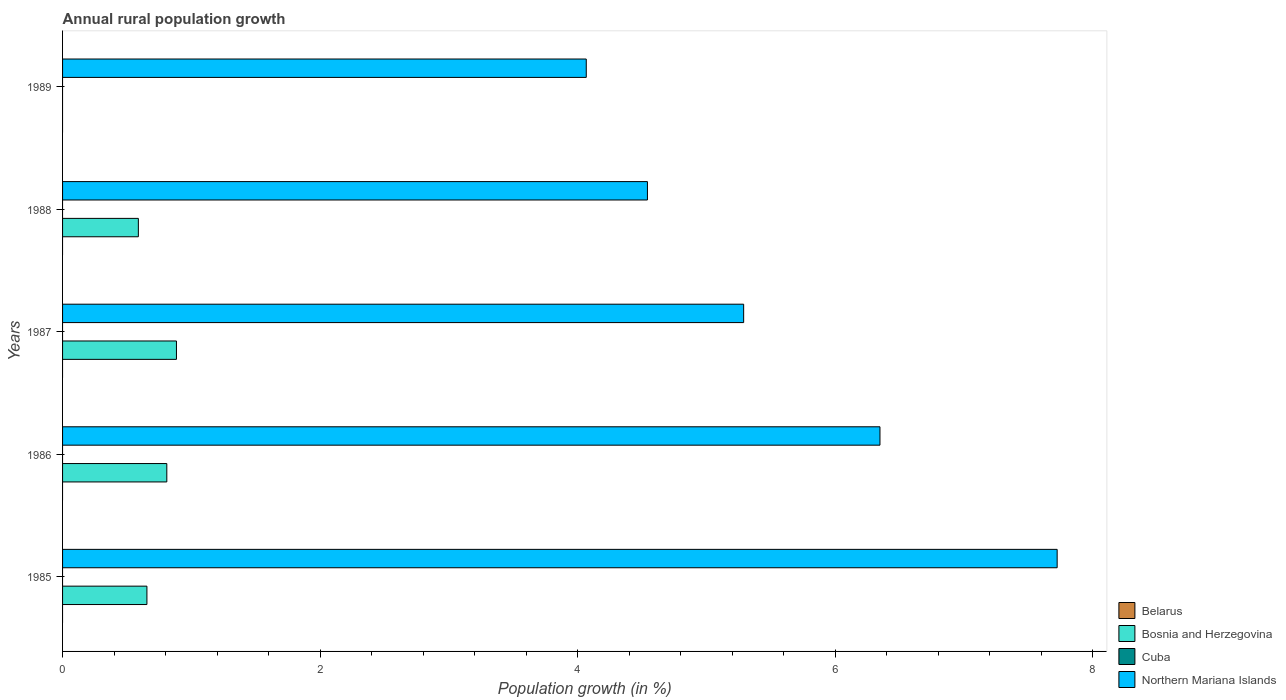Are the number of bars on each tick of the Y-axis equal?
Make the answer very short. No. How many bars are there on the 5th tick from the top?
Your answer should be very brief. 2. How many bars are there on the 1st tick from the bottom?
Provide a succinct answer. 2. In how many cases, is the number of bars for a given year not equal to the number of legend labels?
Offer a very short reply. 5. What is the percentage of rural population growth in Belarus in 1989?
Provide a short and direct response. 0. Across all years, what is the maximum percentage of rural population growth in Northern Mariana Islands?
Provide a short and direct response. 7.72. Across all years, what is the minimum percentage of rural population growth in Cuba?
Offer a very short reply. 0. What is the difference between the percentage of rural population growth in Bosnia and Herzegovina in 1986 and that in 1987?
Keep it short and to the point. -0.07. What is the difference between the percentage of rural population growth in Northern Mariana Islands in 1988 and the percentage of rural population growth in Cuba in 1989?
Offer a terse response. 4.54. What is the average percentage of rural population growth in Cuba per year?
Make the answer very short. 0. In the year 1987, what is the difference between the percentage of rural population growth in Northern Mariana Islands and percentage of rural population growth in Bosnia and Herzegovina?
Provide a short and direct response. 4.4. In how many years, is the percentage of rural population growth in Cuba greater than 0.4 %?
Keep it short and to the point. 0. What is the ratio of the percentage of rural population growth in Northern Mariana Islands in 1985 to that in 1988?
Give a very brief answer. 1.7. What is the difference between the highest and the second highest percentage of rural population growth in Bosnia and Herzegovina?
Ensure brevity in your answer.  0.07. What is the difference between the highest and the lowest percentage of rural population growth in Bosnia and Herzegovina?
Ensure brevity in your answer.  0.88. In how many years, is the percentage of rural population growth in Cuba greater than the average percentage of rural population growth in Cuba taken over all years?
Provide a succinct answer. 0. Is it the case that in every year, the sum of the percentage of rural population growth in Northern Mariana Islands and percentage of rural population growth in Cuba is greater than the sum of percentage of rural population growth in Bosnia and Herzegovina and percentage of rural population growth in Belarus?
Provide a succinct answer. Yes. How many bars are there?
Your answer should be very brief. 9. Are all the bars in the graph horizontal?
Provide a succinct answer. Yes. How many years are there in the graph?
Offer a very short reply. 5. What is the difference between two consecutive major ticks on the X-axis?
Your response must be concise. 2. Are the values on the major ticks of X-axis written in scientific E-notation?
Keep it short and to the point. No. Does the graph contain any zero values?
Provide a short and direct response. Yes. Does the graph contain grids?
Make the answer very short. No. How are the legend labels stacked?
Provide a succinct answer. Vertical. What is the title of the graph?
Give a very brief answer. Annual rural population growth. Does "Togo" appear as one of the legend labels in the graph?
Provide a succinct answer. No. What is the label or title of the X-axis?
Make the answer very short. Population growth (in %). What is the Population growth (in %) in Bosnia and Herzegovina in 1985?
Ensure brevity in your answer.  0.66. What is the Population growth (in %) of Northern Mariana Islands in 1985?
Provide a short and direct response. 7.72. What is the Population growth (in %) of Bosnia and Herzegovina in 1986?
Offer a very short reply. 0.81. What is the Population growth (in %) in Northern Mariana Islands in 1986?
Offer a terse response. 6.35. What is the Population growth (in %) in Bosnia and Herzegovina in 1987?
Your answer should be compact. 0.88. What is the Population growth (in %) of Cuba in 1987?
Keep it short and to the point. 0. What is the Population growth (in %) of Northern Mariana Islands in 1987?
Give a very brief answer. 5.29. What is the Population growth (in %) of Bosnia and Herzegovina in 1988?
Your answer should be compact. 0.59. What is the Population growth (in %) in Northern Mariana Islands in 1988?
Provide a short and direct response. 4.54. What is the Population growth (in %) in Belarus in 1989?
Your answer should be compact. 0. What is the Population growth (in %) of Cuba in 1989?
Your answer should be compact. 0. What is the Population growth (in %) of Northern Mariana Islands in 1989?
Your answer should be very brief. 4.07. Across all years, what is the maximum Population growth (in %) in Bosnia and Herzegovina?
Offer a terse response. 0.88. Across all years, what is the maximum Population growth (in %) of Northern Mariana Islands?
Give a very brief answer. 7.72. Across all years, what is the minimum Population growth (in %) in Bosnia and Herzegovina?
Provide a short and direct response. 0. Across all years, what is the minimum Population growth (in %) in Northern Mariana Islands?
Provide a succinct answer. 4.07. What is the total Population growth (in %) of Bosnia and Herzegovina in the graph?
Your answer should be compact. 2.94. What is the total Population growth (in %) in Cuba in the graph?
Offer a terse response. 0. What is the total Population growth (in %) in Northern Mariana Islands in the graph?
Provide a short and direct response. 27.97. What is the difference between the Population growth (in %) of Bosnia and Herzegovina in 1985 and that in 1986?
Offer a terse response. -0.15. What is the difference between the Population growth (in %) in Northern Mariana Islands in 1985 and that in 1986?
Ensure brevity in your answer.  1.38. What is the difference between the Population growth (in %) of Bosnia and Herzegovina in 1985 and that in 1987?
Make the answer very short. -0.23. What is the difference between the Population growth (in %) in Northern Mariana Islands in 1985 and that in 1987?
Your answer should be compact. 2.43. What is the difference between the Population growth (in %) in Bosnia and Herzegovina in 1985 and that in 1988?
Ensure brevity in your answer.  0.07. What is the difference between the Population growth (in %) of Northern Mariana Islands in 1985 and that in 1988?
Your answer should be compact. 3.18. What is the difference between the Population growth (in %) in Northern Mariana Islands in 1985 and that in 1989?
Your answer should be very brief. 3.66. What is the difference between the Population growth (in %) in Bosnia and Herzegovina in 1986 and that in 1987?
Offer a very short reply. -0.07. What is the difference between the Population growth (in %) in Northern Mariana Islands in 1986 and that in 1987?
Give a very brief answer. 1.06. What is the difference between the Population growth (in %) in Bosnia and Herzegovina in 1986 and that in 1988?
Offer a terse response. 0.22. What is the difference between the Population growth (in %) in Northern Mariana Islands in 1986 and that in 1988?
Your response must be concise. 1.81. What is the difference between the Population growth (in %) of Northern Mariana Islands in 1986 and that in 1989?
Ensure brevity in your answer.  2.28. What is the difference between the Population growth (in %) of Bosnia and Herzegovina in 1987 and that in 1988?
Keep it short and to the point. 0.3. What is the difference between the Population growth (in %) in Northern Mariana Islands in 1987 and that in 1988?
Provide a succinct answer. 0.75. What is the difference between the Population growth (in %) of Northern Mariana Islands in 1987 and that in 1989?
Offer a terse response. 1.22. What is the difference between the Population growth (in %) of Northern Mariana Islands in 1988 and that in 1989?
Give a very brief answer. 0.47. What is the difference between the Population growth (in %) of Bosnia and Herzegovina in 1985 and the Population growth (in %) of Northern Mariana Islands in 1986?
Give a very brief answer. -5.69. What is the difference between the Population growth (in %) of Bosnia and Herzegovina in 1985 and the Population growth (in %) of Northern Mariana Islands in 1987?
Your response must be concise. -4.63. What is the difference between the Population growth (in %) in Bosnia and Herzegovina in 1985 and the Population growth (in %) in Northern Mariana Islands in 1988?
Give a very brief answer. -3.89. What is the difference between the Population growth (in %) of Bosnia and Herzegovina in 1985 and the Population growth (in %) of Northern Mariana Islands in 1989?
Your answer should be very brief. -3.41. What is the difference between the Population growth (in %) in Bosnia and Herzegovina in 1986 and the Population growth (in %) in Northern Mariana Islands in 1987?
Your response must be concise. -4.48. What is the difference between the Population growth (in %) of Bosnia and Herzegovina in 1986 and the Population growth (in %) of Northern Mariana Islands in 1988?
Offer a terse response. -3.73. What is the difference between the Population growth (in %) in Bosnia and Herzegovina in 1986 and the Population growth (in %) in Northern Mariana Islands in 1989?
Your response must be concise. -3.26. What is the difference between the Population growth (in %) in Bosnia and Herzegovina in 1987 and the Population growth (in %) in Northern Mariana Islands in 1988?
Make the answer very short. -3.66. What is the difference between the Population growth (in %) of Bosnia and Herzegovina in 1987 and the Population growth (in %) of Northern Mariana Islands in 1989?
Provide a short and direct response. -3.18. What is the difference between the Population growth (in %) in Bosnia and Herzegovina in 1988 and the Population growth (in %) in Northern Mariana Islands in 1989?
Provide a short and direct response. -3.48. What is the average Population growth (in %) of Belarus per year?
Provide a succinct answer. 0. What is the average Population growth (in %) of Bosnia and Herzegovina per year?
Provide a short and direct response. 0.59. What is the average Population growth (in %) in Cuba per year?
Provide a succinct answer. 0. What is the average Population growth (in %) of Northern Mariana Islands per year?
Offer a terse response. 5.59. In the year 1985, what is the difference between the Population growth (in %) in Bosnia and Herzegovina and Population growth (in %) in Northern Mariana Islands?
Your answer should be very brief. -7.07. In the year 1986, what is the difference between the Population growth (in %) in Bosnia and Herzegovina and Population growth (in %) in Northern Mariana Islands?
Make the answer very short. -5.54. In the year 1987, what is the difference between the Population growth (in %) of Bosnia and Herzegovina and Population growth (in %) of Northern Mariana Islands?
Make the answer very short. -4.4. In the year 1988, what is the difference between the Population growth (in %) of Bosnia and Herzegovina and Population growth (in %) of Northern Mariana Islands?
Offer a terse response. -3.95. What is the ratio of the Population growth (in %) in Bosnia and Herzegovina in 1985 to that in 1986?
Make the answer very short. 0.81. What is the ratio of the Population growth (in %) in Northern Mariana Islands in 1985 to that in 1986?
Give a very brief answer. 1.22. What is the ratio of the Population growth (in %) in Bosnia and Herzegovina in 1985 to that in 1987?
Keep it short and to the point. 0.74. What is the ratio of the Population growth (in %) in Northern Mariana Islands in 1985 to that in 1987?
Keep it short and to the point. 1.46. What is the ratio of the Population growth (in %) of Bosnia and Herzegovina in 1985 to that in 1988?
Give a very brief answer. 1.11. What is the ratio of the Population growth (in %) in Northern Mariana Islands in 1985 to that in 1988?
Provide a short and direct response. 1.7. What is the ratio of the Population growth (in %) of Northern Mariana Islands in 1985 to that in 1989?
Keep it short and to the point. 1.9. What is the ratio of the Population growth (in %) of Bosnia and Herzegovina in 1986 to that in 1987?
Your response must be concise. 0.92. What is the ratio of the Population growth (in %) in Northern Mariana Islands in 1986 to that in 1987?
Your response must be concise. 1.2. What is the ratio of the Population growth (in %) of Bosnia and Herzegovina in 1986 to that in 1988?
Your answer should be very brief. 1.38. What is the ratio of the Population growth (in %) of Northern Mariana Islands in 1986 to that in 1988?
Provide a short and direct response. 1.4. What is the ratio of the Population growth (in %) in Northern Mariana Islands in 1986 to that in 1989?
Make the answer very short. 1.56. What is the ratio of the Population growth (in %) in Bosnia and Herzegovina in 1987 to that in 1988?
Your answer should be very brief. 1.5. What is the ratio of the Population growth (in %) of Northern Mariana Islands in 1987 to that in 1988?
Offer a very short reply. 1.16. What is the ratio of the Population growth (in %) of Northern Mariana Islands in 1987 to that in 1989?
Provide a short and direct response. 1.3. What is the ratio of the Population growth (in %) in Northern Mariana Islands in 1988 to that in 1989?
Your response must be concise. 1.12. What is the difference between the highest and the second highest Population growth (in %) in Bosnia and Herzegovina?
Offer a terse response. 0.07. What is the difference between the highest and the second highest Population growth (in %) of Northern Mariana Islands?
Offer a very short reply. 1.38. What is the difference between the highest and the lowest Population growth (in %) of Bosnia and Herzegovina?
Make the answer very short. 0.88. What is the difference between the highest and the lowest Population growth (in %) of Northern Mariana Islands?
Offer a very short reply. 3.66. 